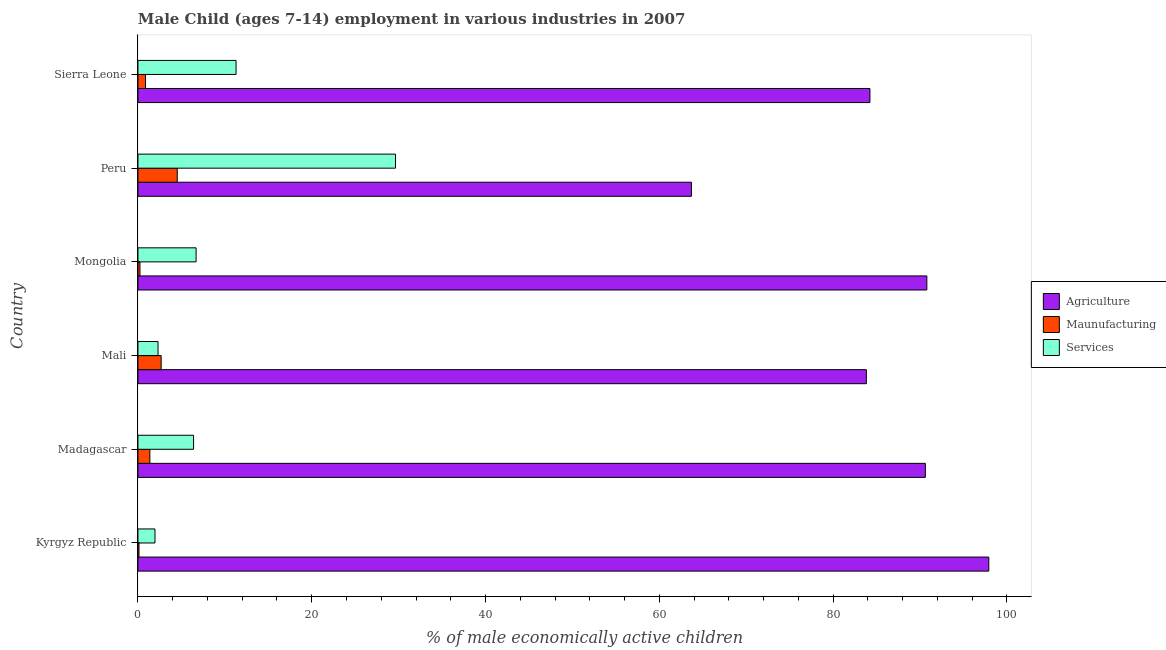Are the number of bars per tick equal to the number of legend labels?
Offer a very short reply. Yes. Are the number of bars on each tick of the Y-axis equal?
Your answer should be compact. Yes. How many bars are there on the 6th tick from the top?
Ensure brevity in your answer.  3. What is the label of the 1st group of bars from the top?
Your response must be concise. Sierra Leone. What is the percentage of economically active children in manufacturing in Peru?
Make the answer very short. 4.52. Across all countries, what is the maximum percentage of economically active children in agriculture?
Your response must be concise. 97.92. Across all countries, what is the minimum percentage of economically active children in agriculture?
Ensure brevity in your answer.  63.7. In which country was the percentage of economically active children in manufacturing maximum?
Provide a short and direct response. Peru. In which country was the percentage of economically active children in manufacturing minimum?
Your response must be concise. Kyrgyz Republic. What is the total percentage of economically active children in agriculture in the graph?
Provide a succinct answer. 511.1. What is the difference between the percentage of economically active children in agriculture in Mali and that in Sierra Leone?
Ensure brevity in your answer.  -0.41. What is the difference between the percentage of economically active children in agriculture in Kyrgyz Republic and the percentage of economically active children in services in Sierra Leone?
Offer a terse response. 86.63. What is the average percentage of economically active children in manufacturing per country?
Your response must be concise. 1.63. What is the difference between the percentage of economically active children in services and percentage of economically active children in manufacturing in Peru?
Your response must be concise. 25.12. In how many countries, is the percentage of economically active children in agriculture greater than 20 %?
Provide a succinct answer. 6. What is the ratio of the percentage of economically active children in services in Mali to that in Peru?
Your answer should be very brief. 0.08. Is the difference between the percentage of economically active children in services in Mali and Sierra Leone greater than the difference between the percentage of economically active children in agriculture in Mali and Sierra Leone?
Give a very brief answer. No. What is the difference between the highest and the second highest percentage of economically active children in manufacturing?
Keep it short and to the point. 1.85. What is the difference between the highest and the lowest percentage of economically active children in agriculture?
Give a very brief answer. 34.22. In how many countries, is the percentage of economically active children in services greater than the average percentage of economically active children in services taken over all countries?
Make the answer very short. 2. What does the 3rd bar from the top in Mongolia represents?
Make the answer very short. Agriculture. What does the 1st bar from the bottom in Kyrgyz Republic represents?
Give a very brief answer. Agriculture. Is it the case that in every country, the sum of the percentage of economically active children in agriculture and percentage of economically active children in manufacturing is greater than the percentage of economically active children in services?
Offer a very short reply. Yes. Are all the bars in the graph horizontal?
Ensure brevity in your answer.  Yes. How many countries are there in the graph?
Offer a terse response. 6. Are the values on the major ticks of X-axis written in scientific E-notation?
Offer a very short reply. No. How many legend labels are there?
Provide a succinct answer. 3. How are the legend labels stacked?
Offer a terse response. Vertical. What is the title of the graph?
Offer a very short reply. Male Child (ages 7-14) employment in various industries in 2007. What is the label or title of the X-axis?
Your response must be concise. % of male economically active children. What is the label or title of the Y-axis?
Provide a succinct answer. Country. What is the % of male economically active children in Agriculture in Kyrgyz Republic?
Ensure brevity in your answer.  97.92. What is the % of male economically active children in Maunufacturing in Kyrgyz Republic?
Make the answer very short. 0.12. What is the % of male economically active children of Services in Kyrgyz Republic?
Keep it short and to the point. 1.96. What is the % of male economically active children of Agriculture in Madagascar?
Your response must be concise. 90.62. What is the % of male economically active children in Maunufacturing in Madagascar?
Make the answer very short. 1.37. What is the % of male economically active children in Agriculture in Mali?
Provide a succinct answer. 83.83. What is the % of male economically active children in Maunufacturing in Mali?
Make the answer very short. 2.67. What is the % of male economically active children of Services in Mali?
Give a very brief answer. 2.31. What is the % of male economically active children in Agriculture in Mongolia?
Make the answer very short. 90.79. What is the % of male economically active children in Maunufacturing in Mongolia?
Keep it short and to the point. 0.23. What is the % of male economically active children of Services in Mongolia?
Provide a short and direct response. 6.69. What is the % of male economically active children of Agriculture in Peru?
Your answer should be compact. 63.7. What is the % of male economically active children in Maunufacturing in Peru?
Make the answer very short. 4.52. What is the % of male economically active children of Services in Peru?
Ensure brevity in your answer.  29.64. What is the % of male economically active children in Agriculture in Sierra Leone?
Your answer should be compact. 84.24. What is the % of male economically active children of Maunufacturing in Sierra Leone?
Offer a terse response. 0.87. What is the % of male economically active children in Services in Sierra Leone?
Make the answer very short. 11.29. Across all countries, what is the maximum % of male economically active children in Agriculture?
Your response must be concise. 97.92. Across all countries, what is the maximum % of male economically active children in Maunufacturing?
Your answer should be compact. 4.52. Across all countries, what is the maximum % of male economically active children of Services?
Your answer should be compact. 29.64. Across all countries, what is the minimum % of male economically active children of Agriculture?
Provide a succinct answer. 63.7. Across all countries, what is the minimum % of male economically active children of Maunufacturing?
Ensure brevity in your answer.  0.12. Across all countries, what is the minimum % of male economically active children of Services?
Ensure brevity in your answer.  1.96. What is the total % of male economically active children of Agriculture in the graph?
Your response must be concise. 511.1. What is the total % of male economically active children of Maunufacturing in the graph?
Your answer should be very brief. 9.78. What is the total % of male economically active children of Services in the graph?
Your answer should be very brief. 58.29. What is the difference between the % of male economically active children of Agriculture in Kyrgyz Republic and that in Madagascar?
Ensure brevity in your answer.  7.3. What is the difference between the % of male economically active children in Maunufacturing in Kyrgyz Republic and that in Madagascar?
Offer a very short reply. -1.25. What is the difference between the % of male economically active children in Services in Kyrgyz Republic and that in Madagascar?
Offer a terse response. -4.44. What is the difference between the % of male economically active children in Agriculture in Kyrgyz Republic and that in Mali?
Provide a short and direct response. 14.09. What is the difference between the % of male economically active children of Maunufacturing in Kyrgyz Republic and that in Mali?
Make the answer very short. -2.55. What is the difference between the % of male economically active children of Services in Kyrgyz Republic and that in Mali?
Your response must be concise. -0.35. What is the difference between the % of male economically active children of Agriculture in Kyrgyz Republic and that in Mongolia?
Give a very brief answer. 7.13. What is the difference between the % of male economically active children in Maunufacturing in Kyrgyz Republic and that in Mongolia?
Offer a very short reply. -0.11. What is the difference between the % of male economically active children of Services in Kyrgyz Republic and that in Mongolia?
Make the answer very short. -4.73. What is the difference between the % of male economically active children of Agriculture in Kyrgyz Republic and that in Peru?
Ensure brevity in your answer.  34.22. What is the difference between the % of male economically active children in Maunufacturing in Kyrgyz Republic and that in Peru?
Your answer should be very brief. -4.4. What is the difference between the % of male economically active children in Services in Kyrgyz Republic and that in Peru?
Keep it short and to the point. -27.68. What is the difference between the % of male economically active children in Agriculture in Kyrgyz Republic and that in Sierra Leone?
Your answer should be very brief. 13.68. What is the difference between the % of male economically active children in Maunufacturing in Kyrgyz Republic and that in Sierra Leone?
Provide a succinct answer. -0.75. What is the difference between the % of male economically active children in Services in Kyrgyz Republic and that in Sierra Leone?
Provide a short and direct response. -9.33. What is the difference between the % of male economically active children of Agriculture in Madagascar and that in Mali?
Give a very brief answer. 6.79. What is the difference between the % of male economically active children of Services in Madagascar and that in Mali?
Your response must be concise. 4.09. What is the difference between the % of male economically active children in Agriculture in Madagascar and that in Mongolia?
Offer a very short reply. -0.17. What is the difference between the % of male economically active children in Maunufacturing in Madagascar and that in Mongolia?
Provide a succinct answer. 1.14. What is the difference between the % of male economically active children in Services in Madagascar and that in Mongolia?
Keep it short and to the point. -0.29. What is the difference between the % of male economically active children of Agriculture in Madagascar and that in Peru?
Offer a very short reply. 26.92. What is the difference between the % of male economically active children of Maunufacturing in Madagascar and that in Peru?
Provide a short and direct response. -3.15. What is the difference between the % of male economically active children of Services in Madagascar and that in Peru?
Your answer should be very brief. -23.24. What is the difference between the % of male economically active children in Agriculture in Madagascar and that in Sierra Leone?
Your response must be concise. 6.38. What is the difference between the % of male economically active children of Maunufacturing in Madagascar and that in Sierra Leone?
Offer a very short reply. 0.5. What is the difference between the % of male economically active children of Services in Madagascar and that in Sierra Leone?
Your answer should be compact. -4.89. What is the difference between the % of male economically active children of Agriculture in Mali and that in Mongolia?
Offer a terse response. -6.96. What is the difference between the % of male economically active children of Maunufacturing in Mali and that in Mongolia?
Your answer should be compact. 2.44. What is the difference between the % of male economically active children of Services in Mali and that in Mongolia?
Provide a short and direct response. -4.38. What is the difference between the % of male economically active children in Agriculture in Mali and that in Peru?
Your answer should be compact. 20.13. What is the difference between the % of male economically active children in Maunufacturing in Mali and that in Peru?
Provide a short and direct response. -1.85. What is the difference between the % of male economically active children of Services in Mali and that in Peru?
Ensure brevity in your answer.  -27.33. What is the difference between the % of male economically active children in Agriculture in Mali and that in Sierra Leone?
Your answer should be compact. -0.41. What is the difference between the % of male economically active children in Maunufacturing in Mali and that in Sierra Leone?
Your answer should be very brief. 1.8. What is the difference between the % of male economically active children of Services in Mali and that in Sierra Leone?
Give a very brief answer. -8.98. What is the difference between the % of male economically active children in Agriculture in Mongolia and that in Peru?
Your response must be concise. 27.09. What is the difference between the % of male economically active children of Maunufacturing in Mongolia and that in Peru?
Your answer should be compact. -4.29. What is the difference between the % of male economically active children in Services in Mongolia and that in Peru?
Keep it short and to the point. -22.95. What is the difference between the % of male economically active children of Agriculture in Mongolia and that in Sierra Leone?
Your answer should be very brief. 6.55. What is the difference between the % of male economically active children of Maunufacturing in Mongolia and that in Sierra Leone?
Make the answer very short. -0.64. What is the difference between the % of male economically active children of Services in Mongolia and that in Sierra Leone?
Give a very brief answer. -4.6. What is the difference between the % of male economically active children of Agriculture in Peru and that in Sierra Leone?
Provide a succinct answer. -20.54. What is the difference between the % of male economically active children of Maunufacturing in Peru and that in Sierra Leone?
Give a very brief answer. 3.65. What is the difference between the % of male economically active children in Services in Peru and that in Sierra Leone?
Make the answer very short. 18.35. What is the difference between the % of male economically active children of Agriculture in Kyrgyz Republic and the % of male economically active children of Maunufacturing in Madagascar?
Provide a succinct answer. 96.55. What is the difference between the % of male economically active children of Agriculture in Kyrgyz Republic and the % of male economically active children of Services in Madagascar?
Provide a short and direct response. 91.52. What is the difference between the % of male economically active children of Maunufacturing in Kyrgyz Republic and the % of male economically active children of Services in Madagascar?
Offer a very short reply. -6.28. What is the difference between the % of male economically active children in Agriculture in Kyrgyz Republic and the % of male economically active children in Maunufacturing in Mali?
Offer a very short reply. 95.25. What is the difference between the % of male economically active children in Agriculture in Kyrgyz Republic and the % of male economically active children in Services in Mali?
Make the answer very short. 95.61. What is the difference between the % of male economically active children in Maunufacturing in Kyrgyz Republic and the % of male economically active children in Services in Mali?
Make the answer very short. -2.19. What is the difference between the % of male economically active children of Agriculture in Kyrgyz Republic and the % of male economically active children of Maunufacturing in Mongolia?
Provide a short and direct response. 97.69. What is the difference between the % of male economically active children of Agriculture in Kyrgyz Republic and the % of male economically active children of Services in Mongolia?
Your response must be concise. 91.23. What is the difference between the % of male economically active children of Maunufacturing in Kyrgyz Republic and the % of male economically active children of Services in Mongolia?
Keep it short and to the point. -6.57. What is the difference between the % of male economically active children of Agriculture in Kyrgyz Republic and the % of male economically active children of Maunufacturing in Peru?
Give a very brief answer. 93.4. What is the difference between the % of male economically active children of Agriculture in Kyrgyz Republic and the % of male economically active children of Services in Peru?
Give a very brief answer. 68.28. What is the difference between the % of male economically active children of Maunufacturing in Kyrgyz Republic and the % of male economically active children of Services in Peru?
Offer a terse response. -29.52. What is the difference between the % of male economically active children in Agriculture in Kyrgyz Republic and the % of male economically active children in Maunufacturing in Sierra Leone?
Make the answer very short. 97.05. What is the difference between the % of male economically active children of Agriculture in Kyrgyz Republic and the % of male economically active children of Services in Sierra Leone?
Your answer should be very brief. 86.63. What is the difference between the % of male economically active children of Maunufacturing in Kyrgyz Republic and the % of male economically active children of Services in Sierra Leone?
Give a very brief answer. -11.17. What is the difference between the % of male economically active children of Agriculture in Madagascar and the % of male economically active children of Maunufacturing in Mali?
Give a very brief answer. 87.95. What is the difference between the % of male economically active children in Agriculture in Madagascar and the % of male economically active children in Services in Mali?
Provide a succinct answer. 88.31. What is the difference between the % of male economically active children in Maunufacturing in Madagascar and the % of male economically active children in Services in Mali?
Provide a short and direct response. -0.94. What is the difference between the % of male economically active children in Agriculture in Madagascar and the % of male economically active children in Maunufacturing in Mongolia?
Your response must be concise. 90.39. What is the difference between the % of male economically active children in Agriculture in Madagascar and the % of male economically active children in Services in Mongolia?
Ensure brevity in your answer.  83.93. What is the difference between the % of male economically active children in Maunufacturing in Madagascar and the % of male economically active children in Services in Mongolia?
Ensure brevity in your answer.  -5.32. What is the difference between the % of male economically active children of Agriculture in Madagascar and the % of male economically active children of Maunufacturing in Peru?
Your response must be concise. 86.1. What is the difference between the % of male economically active children of Agriculture in Madagascar and the % of male economically active children of Services in Peru?
Provide a short and direct response. 60.98. What is the difference between the % of male economically active children of Maunufacturing in Madagascar and the % of male economically active children of Services in Peru?
Your answer should be very brief. -28.27. What is the difference between the % of male economically active children of Agriculture in Madagascar and the % of male economically active children of Maunufacturing in Sierra Leone?
Your response must be concise. 89.75. What is the difference between the % of male economically active children of Agriculture in Madagascar and the % of male economically active children of Services in Sierra Leone?
Provide a succinct answer. 79.33. What is the difference between the % of male economically active children of Maunufacturing in Madagascar and the % of male economically active children of Services in Sierra Leone?
Keep it short and to the point. -9.92. What is the difference between the % of male economically active children in Agriculture in Mali and the % of male economically active children in Maunufacturing in Mongolia?
Offer a very short reply. 83.6. What is the difference between the % of male economically active children in Agriculture in Mali and the % of male economically active children in Services in Mongolia?
Your answer should be compact. 77.14. What is the difference between the % of male economically active children in Maunufacturing in Mali and the % of male economically active children in Services in Mongolia?
Your answer should be very brief. -4.02. What is the difference between the % of male economically active children in Agriculture in Mali and the % of male economically active children in Maunufacturing in Peru?
Provide a short and direct response. 79.31. What is the difference between the % of male economically active children in Agriculture in Mali and the % of male economically active children in Services in Peru?
Your response must be concise. 54.19. What is the difference between the % of male economically active children of Maunufacturing in Mali and the % of male economically active children of Services in Peru?
Offer a very short reply. -26.97. What is the difference between the % of male economically active children of Agriculture in Mali and the % of male economically active children of Maunufacturing in Sierra Leone?
Make the answer very short. 82.96. What is the difference between the % of male economically active children of Agriculture in Mali and the % of male economically active children of Services in Sierra Leone?
Offer a very short reply. 72.54. What is the difference between the % of male economically active children in Maunufacturing in Mali and the % of male economically active children in Services in Sierra Leone?
Provide a succinct answer. -8.62. What is the difference between the % of male economically active children of Agriculture in Mongolia and the % of male economically active children of Maunufacturing in Peru?
Offer a terse response. 86.27. What is the difference between the % of male economically active children of Agriculture in Mongolia and the % of male economically active children of Services in Peru?
Ensure brevity in your answer.  61.15. What is the difference between the % of male economically active children of Maunufacturing in Mongolia and the % of male economically active children of Services in Peru?
Offer a terse response. -29.41. What is the difference between the % of male economically active children of Agriculture in Mongolia and the % of male economically active children of Maunufacturing in Sierra Leone?
Provide a succinct answer. 89.92. What is the difference between the % of male economically active children of Agriculture in Mongolia and the % of male economically active children of Services in Sierra Leone?
Your answer should be very brief. 79.5. What is the difference between the % of male economically active children of Maunufacturing in Mongolia and the % of male economically active children of Services in Sierra Leone?
Offer a very short reply. -11.06. What is the difference between the % of male economically active children in Agriculture in Peru and the % of male economically active children in Maunufacturing in Sierra Leone?
Offer a terse response. 62.83. What is the difference between the % of male economically active children of Agriculture in Peru and the % of male economically active children of Services in Sierra Leone?
Make the answer very short. 52.41. What is the difference between the % of male economically active children of Maunufacturing in Peru and the % of male economically active children of Services in Sierra Leone?
Your answer should be very brief. -6.77. What is the average % of male economically active children in Agriculture per country?
Make the answer very short. 85.18. What is the average % of male economically active children in Maunufacturing per country?
Your response must be concise. 1.63. What is the average % of male economically active children of Services per country?
Offer a terse response. 9.71. What is the difference between the % of male economically active children of Agriculture and % of male economically active children of Maunufacturing in Kyrgyz Republic?
Your answer should be compact. 97.8. What is the difference between the % of male economically active children of Agriculture and % of male economically active children of Services in Kyrgyz Republic?
Your response must be concise. 95.96. What is the difference between the % of male economically active children in Maunufacturing and % of male economically active children in Services in Kyrgyz Republic?
Provide a short and direct response. -1.84. What is the difference between the % of male economically active children in Agriculture and % of male economically active children in Maunufacturing in Madagascar?
Give a very brief answer. 89.25. What is the difference between the % of male economically active children of Agriculture and % of male economically active children of Services in Madagascar?
Ensure brevity in your answer.  84.22. What is the difference between the % of male economically active children of Maunufacturing and % of male economically active children of Services in Madagascar?
Your answer should be compact. -5.03. What is the difference between the % of male economically active children of Agriculture and % of male economically active children of Maunufacturing in Mali?
Offer a terse response. 81.16. What is the difference between the % of male economically active children in Agriculture and % of male economically active children in Services in Mali?
Keep it short and to the point. 81.52. What is the difference between the % of male economically active children of Maunufacturing and % of male economically active children of Services in Mali?
Ensure brevity in your answer.  0.36. What is the difference between the % of male economically active children of Agriculture and % of male economically active children of Maunufacturing in Mongolia?
Offer a very short reply. 90.56. What is the difference between the % of male economically active children in Agriculture and % of male economically active children in Services in Mongolia?
Make the answer very short. 84.1. What is the difference between the % of male economically active children in Maunufacturing and % of male economically active children in Services in Mongolia?
Your answer should be compact. -6.46. What is the difference between the % of male economically active children in Agriculture and % of male economically active children in Maunufacturing in Peru?
Offer a very short reply. 59.18. What is the difference between the % of male economically active children of Agriculture and % of male economically active children of Services in Peru?
Offer a very short reply. 34.06. What is the difference between the % of male economically active children in Maunufacturing and % of male economically active children in Services in Peru?
Offer a terse response. -25.12. What is the difference between the % of male economically active children of Agriculture and % of male economically active children of Maunufacturing in Sierra Leone?
Give a very brief answer. 83.37. What is the difference between the % of male economically active children of Agriculture and % of male economically active children of Services in Sierra Leone?
Offer a very short reply. 72.95. What is the difference between the % of male economically active children in Maunufacturing and % of male economically active children in Services in Sierra Leone?
Offer a very short reply. -10.42. What is the ratio of the % of male economically active children of Agriculture in Kyrgyz Republic to that in Madagascar?
Give a very brief answer. 1.08. What is the ratio of the % of male economically active children in Maunufacturing in Kyrgyz Republic to that in Madagascar?
Your answer should be compact. 0.09. What is the ratio of the % of male economically active children of Services in Kyrgyz Republic to that in Madagascar?
Provide a succinct answer. 0.31. What is the ratio of the % of male economically active children in Agriculture in Kyrgyz Republic to that in Mali?
Make the answer very short. 1.17. What is the ratio of the % of male economically active children of Maunufacturing in Kyrgyz Republic to that in Mali?
Make the answer very short. 0.04. What is the ratio of the % of male economically active children in Services in Kyrgyz Republic to that in Mali?
Ensure brevity in your answer.  0.85. What is the ratio of the % of male economically active children in Agriculture in Kyrgyz Republic to that in Mongolia?
Offer a terse response. 1.08. What is the ratio of the % of male economically active children of Maunufacturing in Kyrgyz Republic to that in Mongolia?
Keep it short and to the point. 0.52. What is the ratio of the % of male economically active children of Services in Kyrgyz Republic to that in Mongolia?
Offer a very short reply. 0.29. What is the ratio of the % of male economically active children of Agriculture in Kyrgyz Republic to that in Peru?
Make the answer very short. 1.54. What is the ratio of the % of male economically active children in Maunufacturing in Kyrgyz Republic to that in Peru?
Your answer should be very brief. 0.03. What is the ratio of the % of male economically active children in Services in Kyrgyz Republic to that in Peru?
Provide a succinct answer. 0.07. What is the ratio of the % of male economically active children in Agriculture in Kyrgyz Republic to that in Sierra Leone?
Your answer should be compact. 1.16. What is the ratio of the % of male economically active children of Maunufacturing in Kyrgyz Republic to that in Sierra Leone?
Offer a terse response. 0.14. What is the ratio of the % of male economically active children in Services in Kyrgyz Republic to that in Sierra Leone?
Provide a short and direct response. 0.17. What is the ratio of the % of male economically active children in Agriculture in Madagascar to that in Mali?
Give a very brief answer. 1.08. What is the ratio of the % of male economically active children of Maunufacturing in Madagascar to that in Mali?
Offer a very short reply. 0.51. What is the ratio of the % of male economically active children of Services in Madagascar to that in Mali?
Ensure brevity in your answer.  2.77. What is the ratio of the % of male economically active children in Maunufacturing in Madagascar to that in Mongolia?
Your response must be concise. 5.96. What is the ratio of the % of male economically active children in Services in Madagascar to that in Mongolia?
Ensure brevity in your answer.  0.96. What is the ratio of the % of male economically active children in Agriculture in Madagascar to that in Peru?
Provide a short and direct response. 1.42. What is the ratio of the % of male economically active children of Maunufacturing in Madagascar to that in Peru?
Your response must be concise. 0.3. What is the ratio of the % of male economically active children of Services in Madagascar to that in Peru?
Provide a short and direct response. 0.22. What is the ratio of the % of male economically active children in Agriculture in Madagascar to that in Sierra Leone?
Make the answer very short. 1.08. What is the ratio of the % of male economically active children in Maunufacturing in Madagascar to that in Sierra Leone?
Provide a short and direct response. 1.57. What is the ratio of the % of male economically active children in Services in Madagascar to that in Sierra Leone?
Provide a succinct answer. 0.57. What is the ratio of the % of male economically active children of Agriculture in Mali to that in Mongolia?
Offer a very short reply. 0.92. What is the ratio of the % of male economically active children in Maunufacturing in Mali to that in Mongolia?
Provide a succinct answer. 11.61. What is the ratio of the % of male economically active children of Services in Mali to that in Mongolia?
Offer a terse response. 0.35. What is the ratio of the % of male economically active children in Agriculture in Mali to that in Peru?
Offer a terse response. 1.32. What is the ratio of the % of male economically active children in Maunufacturing in Mali to that in Peru?
Your response must be concise. 0.59. What is the ratio of the % of male economically active children in Services in Mali to that in Peru?
Your response must be concise. 0.08. What is the ratio of the % of male economically active children in Maunufacturing in Mali to that in Sierra Leone?
Keep it short and to the point. 3.07. What is the ratio of the % of male economically active children of Services in Mali to that in Sierra Leone?
Offer a terse response. 0.2. What is the ratio of the % of male economically active children of Agriculture in Mongolia to that in Peru?
Offer a very short reply. 1.43. What is the ratio of the % of male economically active children of Maunufacturing in Mongolia to that in Peru?
Keep it short and to the point. 0.05. What is the ratio of the % of male economically active children in Services in Mongolia to that in Peru?
Your answer should be compact. 0.23. What is the ratio of the % of male economically active children of Agriculture in Mongolia to that in Sierra Leone?
Your response must be concise. 1.08. What is the ratio of the % of male economically active children in Maunufacturing in Mongolia to that in Sierra Leone?
Keep it short and to the point. 0.26. What is the ratio of the % of male economically active children in Services in Mongolia to that in Sierra Leone?
Provide a succinct answer. 0.59. What is the ratio of the % of male economically active children of Agriculture in Peru to that in Sierra Leone?
Provide a succinct answer. 0.76. What is the ratio of the % of male economically active children in Maunufacturing in Peru to that in Sierra Leone?
Offer a very short reply. 5.2. What is the ratio of the % of male economically active children of Services in Peru to that in Sierra Leone?
Your answer should be compact. 2.63. What is the difference between the highest and the second highest % of male economically active children in Agriculture?
Give a very brief answer. 7.13. What is the difference between the highest and the second highest % of male economically active children in Maunufacturing?
Keep it short and to the point. 1.85. What is the difference between the highest and the second highest % of male economically active children of Services?
Your answer should be very brief. 18.35. What is the difference between the highest and the lowest % of male economically active children in Agriculture?
Give a very brief answer. 34.22. What is the difference between the highest and the lowest % of male economically active children of Services?
Make the answer very short. 27.68. 